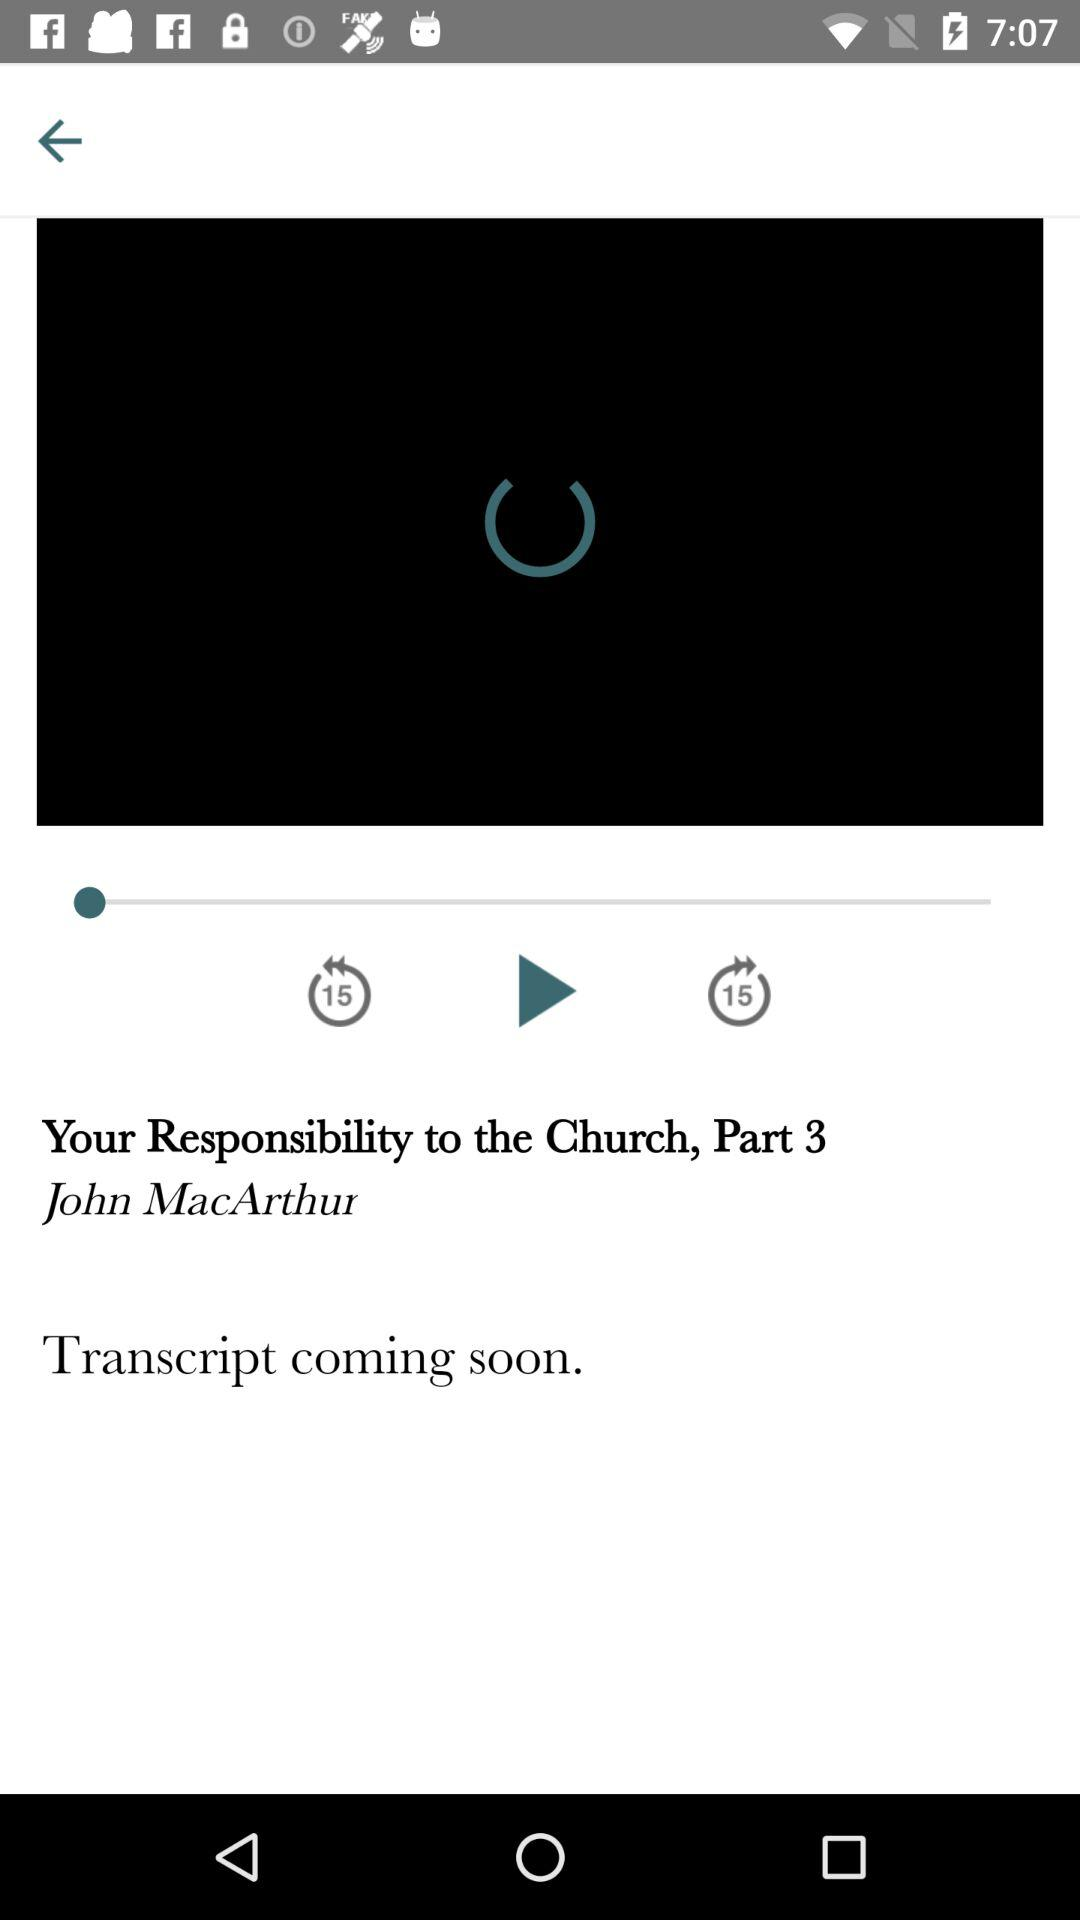What part of the video is this? This is part 3 of the video. 